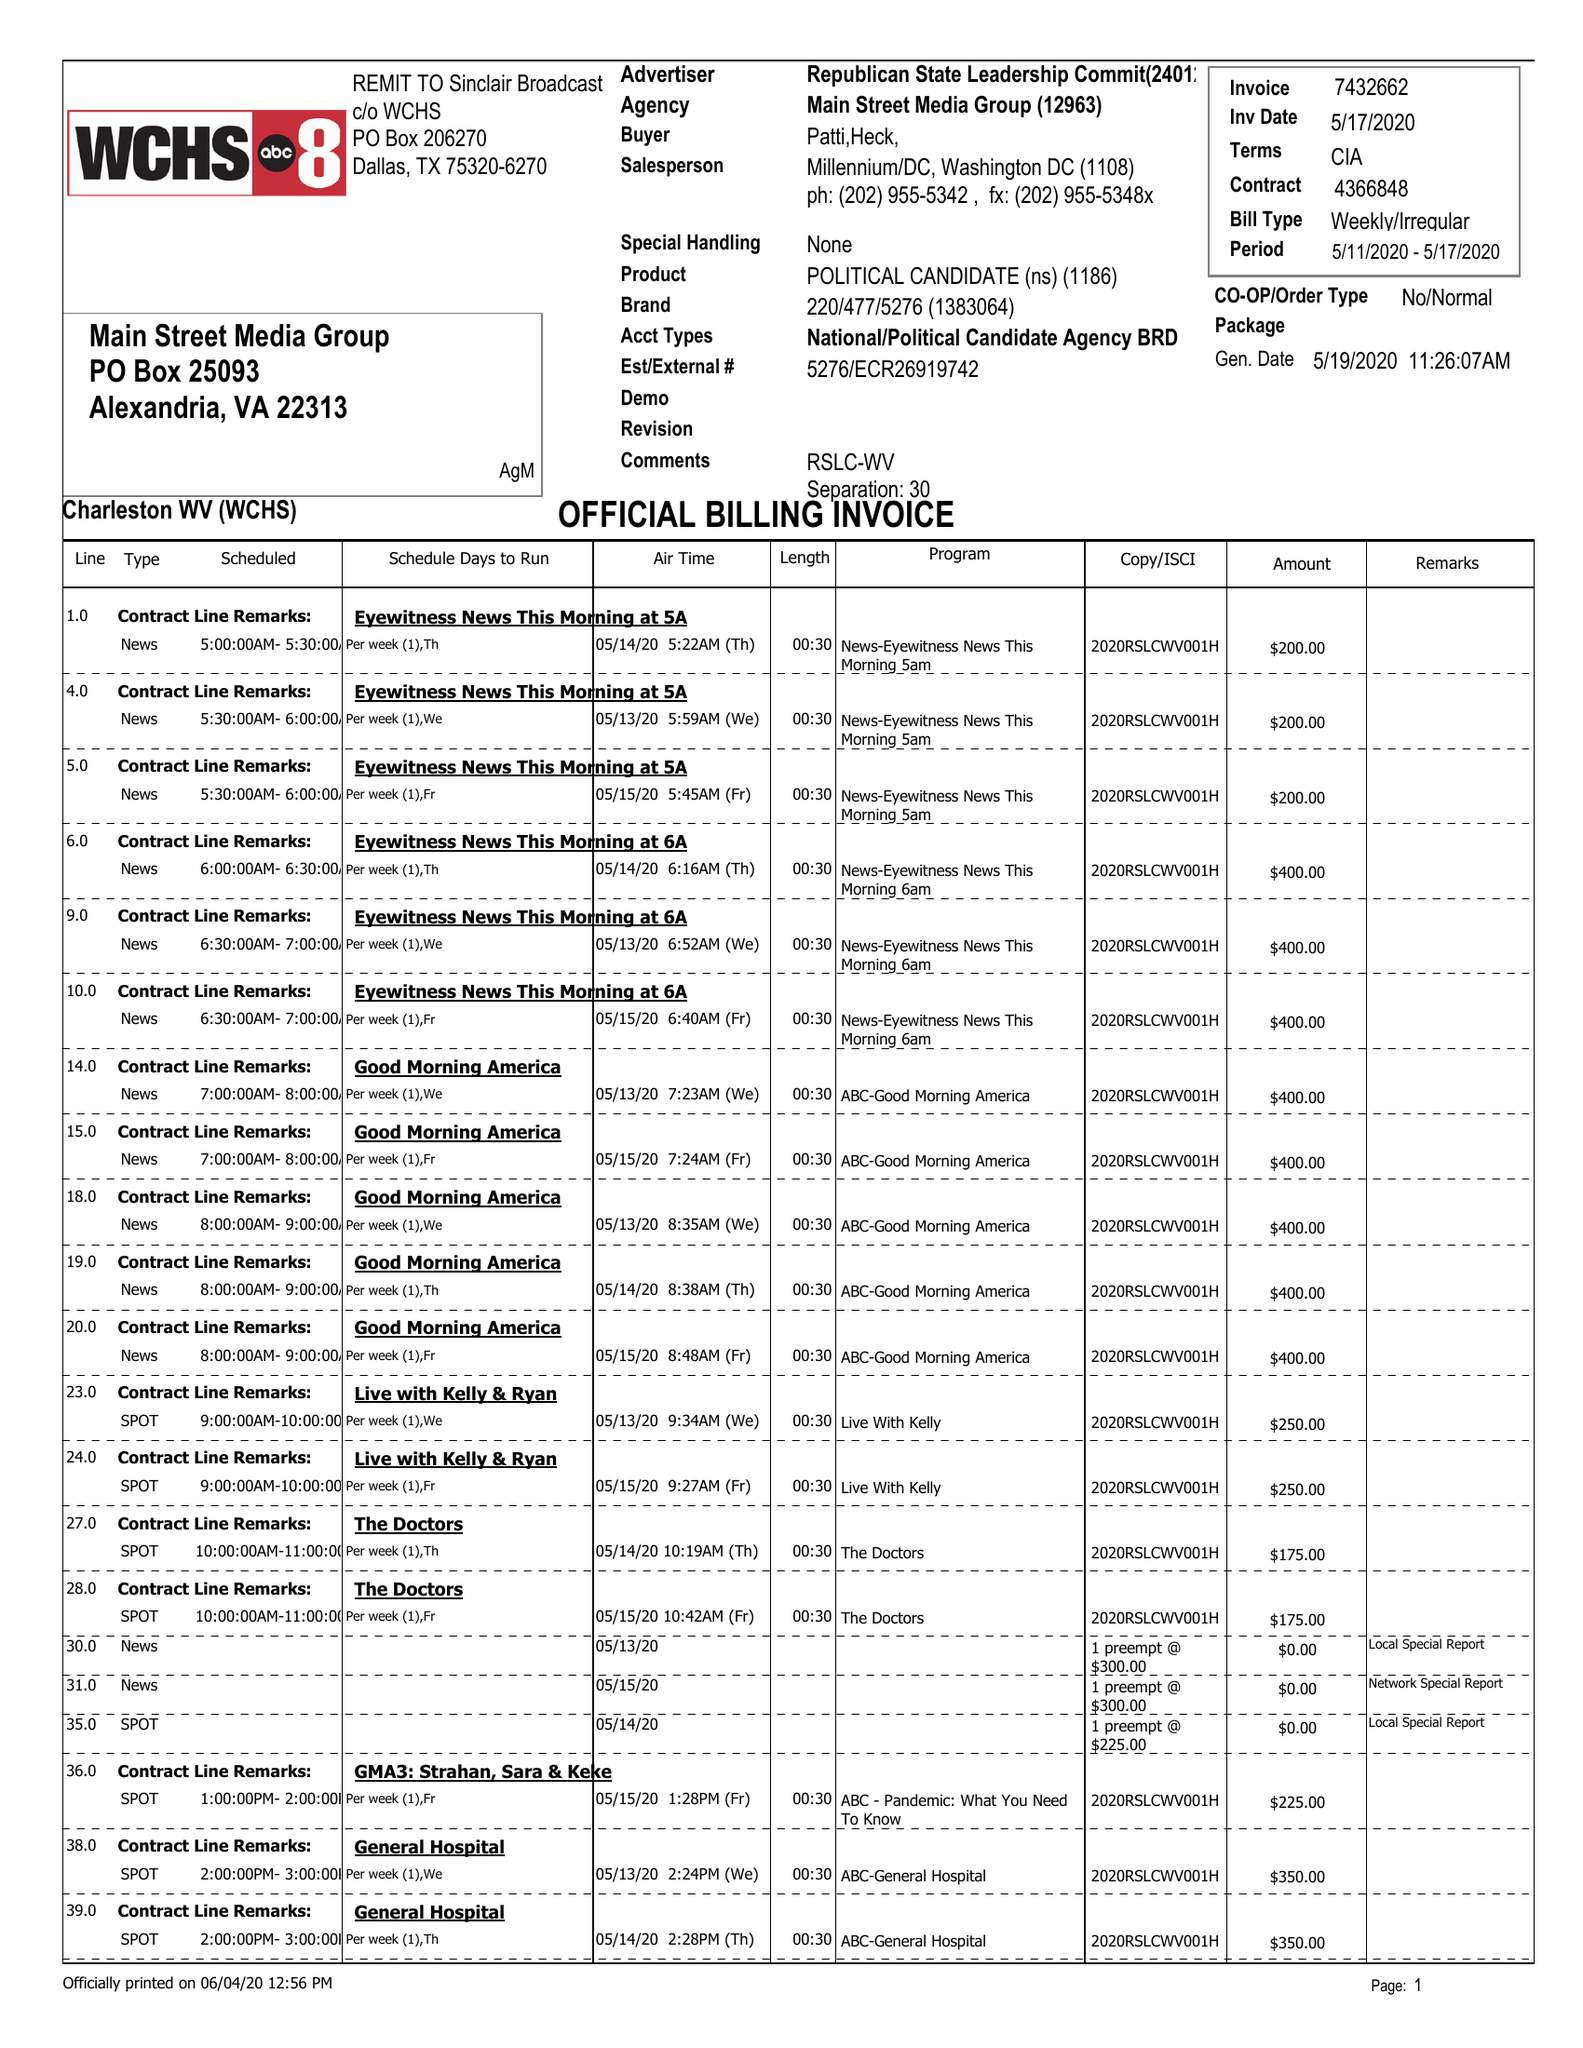What is the value for the gross_amount?
Answer the question using a single word or phrase. 30730.00 